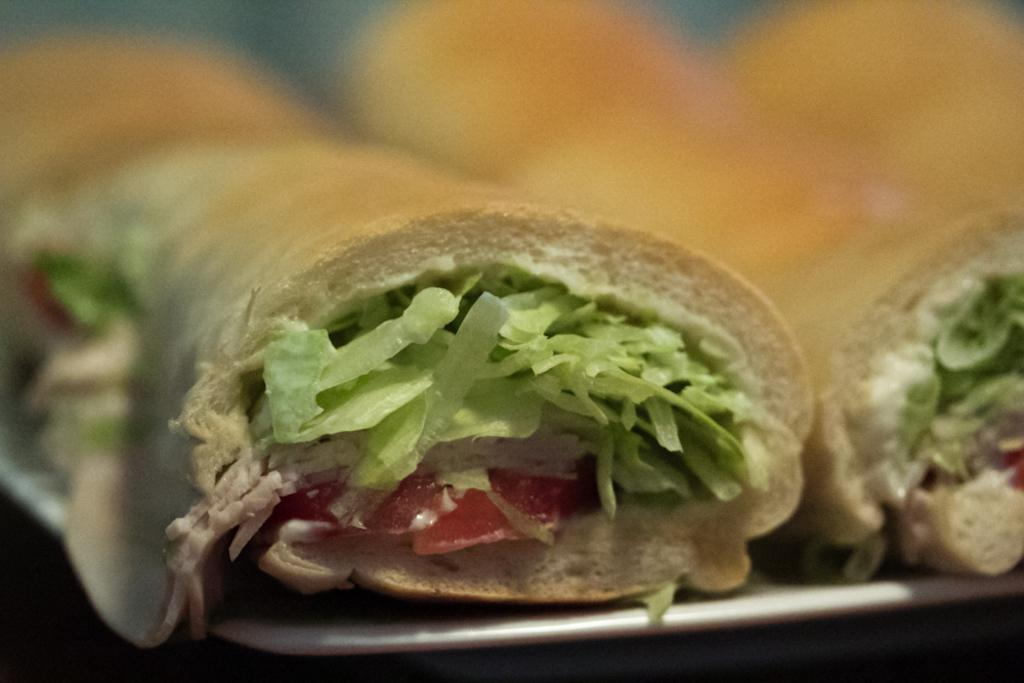What type of food is visible in the image? There is fast food in the image. What time of day is depicted in the image, considering the presence of fast food? The time of day cannot be determined from the image, as fast food can be consumed at any time. How is the fast food being distributed in the image? The image does not show any distribution of fast food; it only shows the food itself. 